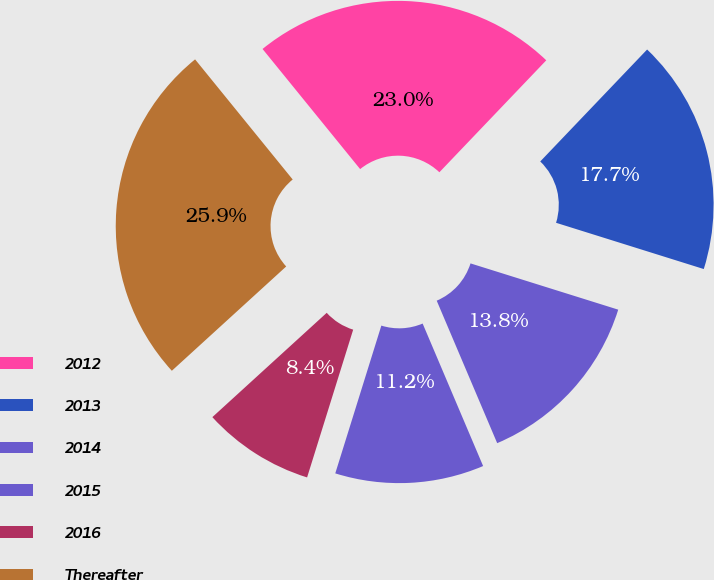Convert chart to OTSL. <chart><loc_0><loc_0><loc_500><loc_500><pie_chart><fcel>2012<fcel>2013<fcel>2014<fcel>2015<fcel>2016<fcel>Thereafter<nl><fcel>22.99%<fcel>17.7%<fcel>13.78%<fcel>11.2%<fcel>8.42%<fcel>25.91%<nl></chart> 